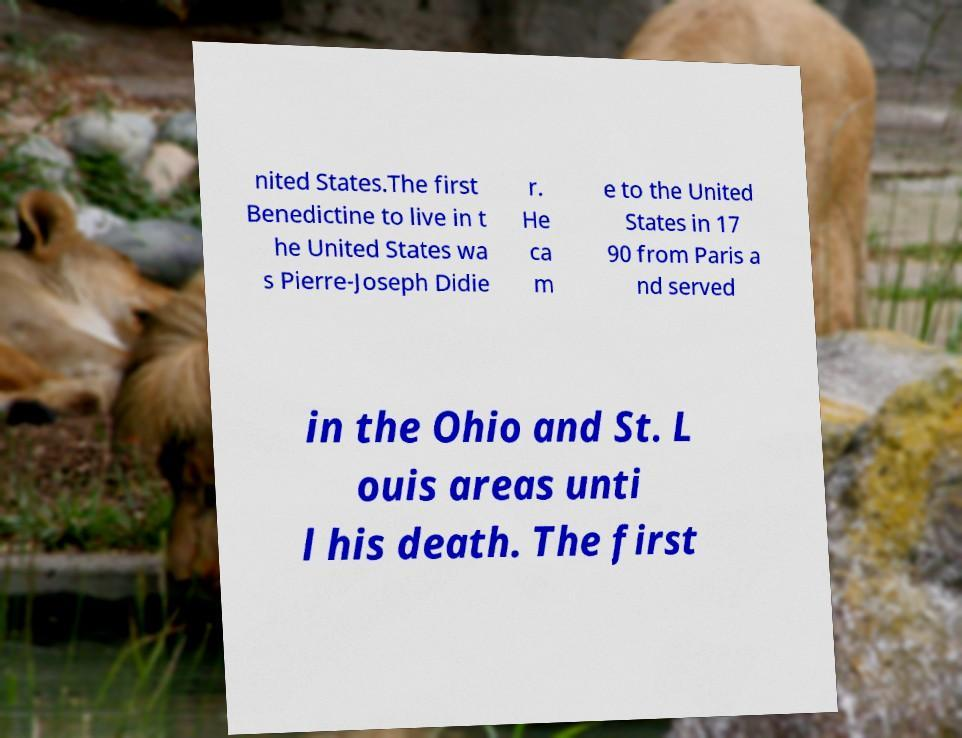Could you assist in decoding the text presented in this image and type it out clearly? nited States.The first Benedictine to live in t he United States wa s Pierre-Joseph Didie r. He ca m e to the United States in 17 90 from Paris a nd served in the Ohio and St. L ouis areas unti l his death. The first 